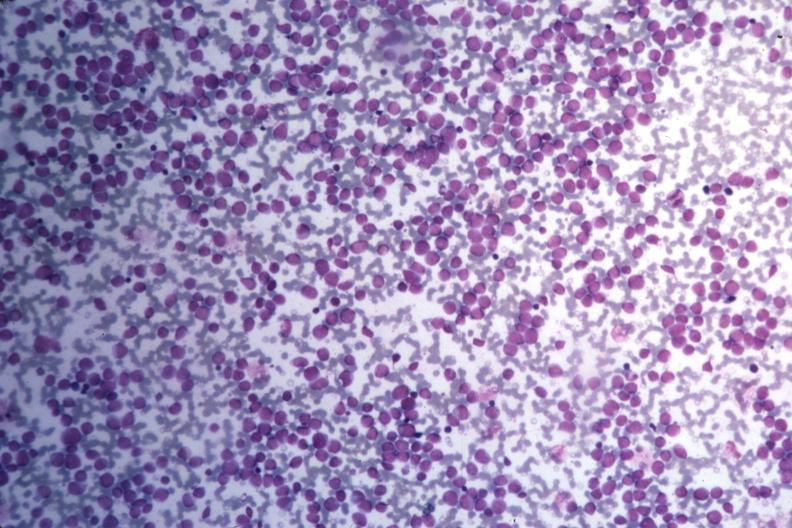what stain many pleomorphic blast cells readily seen?
Answer the question using a single word or phrase. Wrights 